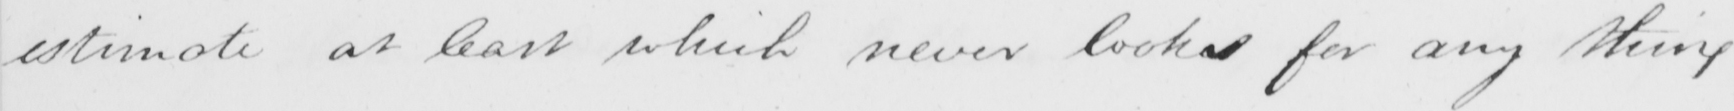What text is written in this handwritten line? estimate at least which never looks for any thing 